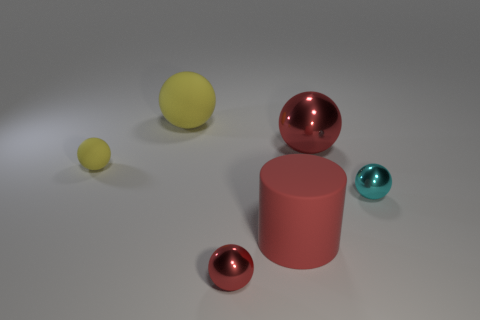Subtract all cyan shiny spheres. How many spheres are left? 4 Subtract all cyan spheres. How many spheres are left? 4 Add 4 purple rubber balls. How many objects exist? 10 Subtract 2 balls. How many balls are left? 3 Subtract all spheres. How many objects are left? 1 Add 3 cyan objects. How many cyan objects exist? 4 Subtract 0 purple spheres. How many objects are left? 6 Subtract all red balls. Subtract all green cylinders. How many balls are left? 3 Subtract all gray cylinders. How many red balls are left? 2 Subtract all red objects. Subtract all small brown rubber blocks. How many objects are left? 3 